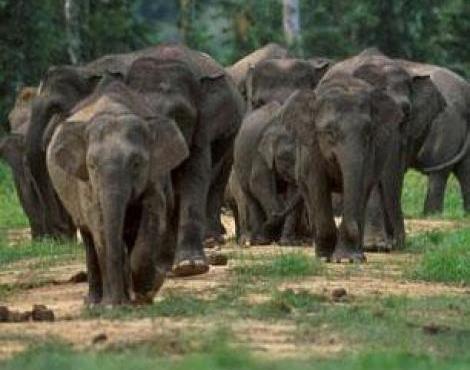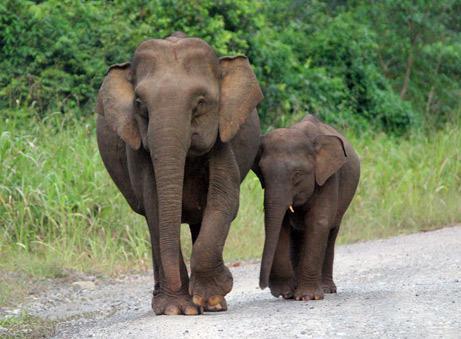The first image is the image on the left, the second image is the image on the right. For the images shown, is this caption "There is one elephant in the image on the left with its trunk curled under toward its mouth." true? Answer yes or no. No. The first image is the image on the left, the second image is the image on the right. Evaluate the accuracy of this statement regarding the images: "An image shows exactly two elephants, with at least one on a path with no greenery on it.". Is it true? Answer yes or no. Yes. 